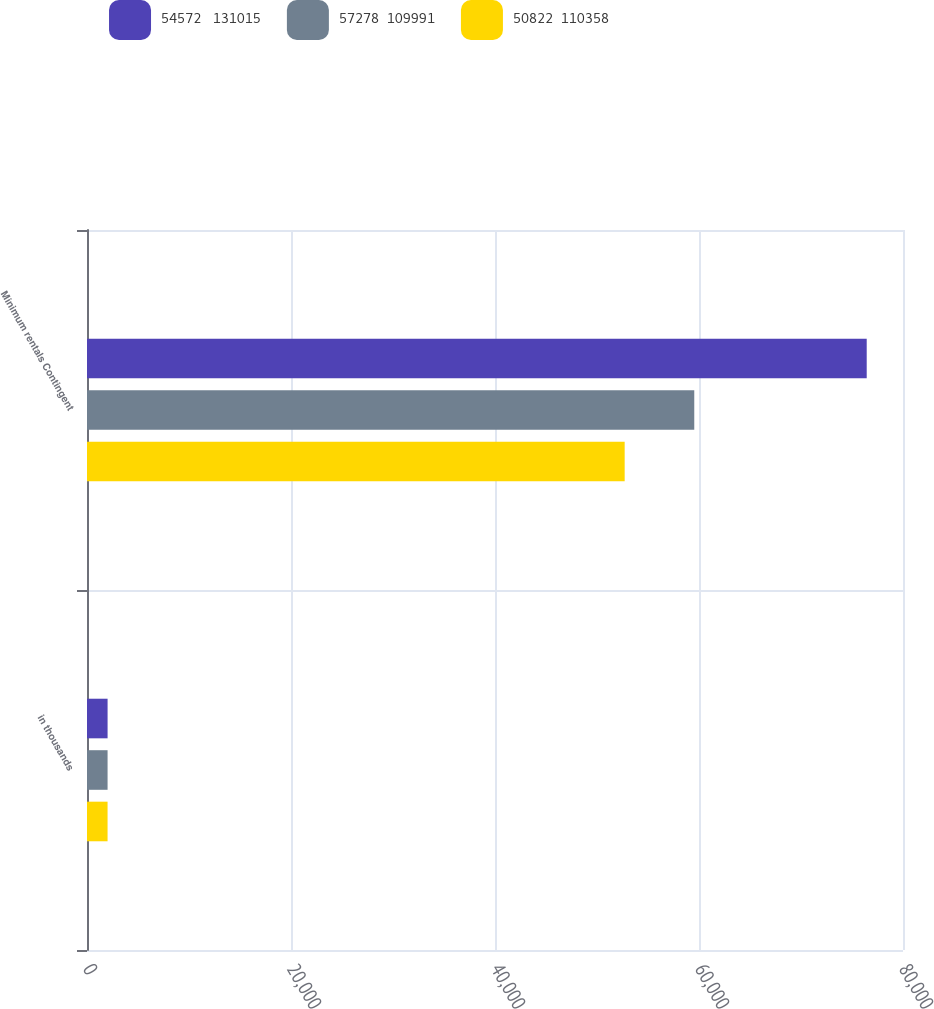Convert chart to OTSL. <chart><loc_0><loc_0><loc_500><loc_500><stacked_bar_chart><ecel><fcel>in thousands<fcel>Minimum rentals Contingent<nl><fcel>54572   131015<fcel>2018<fcel>76443<nl><fcel>57278  109991<fcel>2017<fcel>59536<nl><fcel>50822  110358<fcel>2016<fcel>52713<nl></chart> 